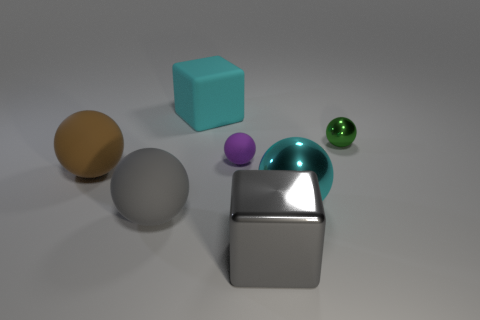What is the size of the object that is the same color as the rubber cube?
Make the answer very short. Large. The sphere in front of the large cyan object on the right side of the large cyan matte thing is made of what material?
Keep it short and to the point. Rubber. There is a small green metallic thing; are there any tiny purple rubber objects in front of it?
Your response must be concise. Yes. Is the number of purple matte things on the left side of the gray rubber thing greater than the number of rubber cylinders?
Keep it short and to the point. No. Are there any balls that have the same color as the tiny metallic object?
Your answer should be very brief. No. There is a metal sphere that is the same size as the cyan block; what color is it?
Keep it short and to the point. Cyan. There is a cyan object that is to the left of the cyan metallic sphere; are there any big cyan rubber blocks on the left side of it?
Provide a short and direct response. No. What is the material of the large cyan object that is in front of the cyan rubber block?
Provide a succinct answer. Metal. Are the small thing that is in front of the green object and the big cube behind the big metal block made of the same material?
Keep it short and to the point. Yes. Are there the same number of large cyan things in front of the tiny green ball and shiny things in front of the big brown sphere?
Your response must be concise. No. 